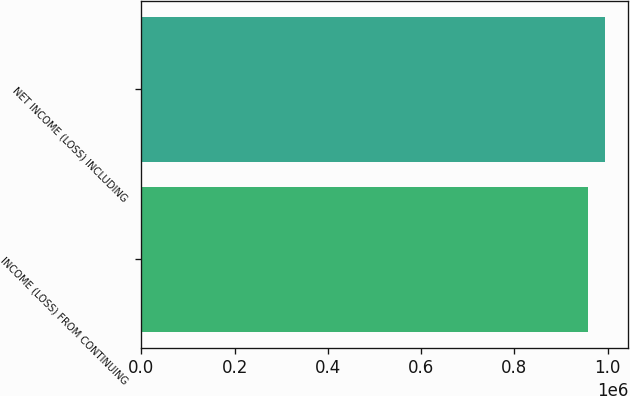<chart> <loc_0><loc_0><loc_500><loc_500><bar_chart><fcel>INCOME (LOSS) FROM CONTINUING<fcel>NET INCOME (LOSS) INCLUDING<nl><fcel>957062<fcel>994661<nl></chart> 